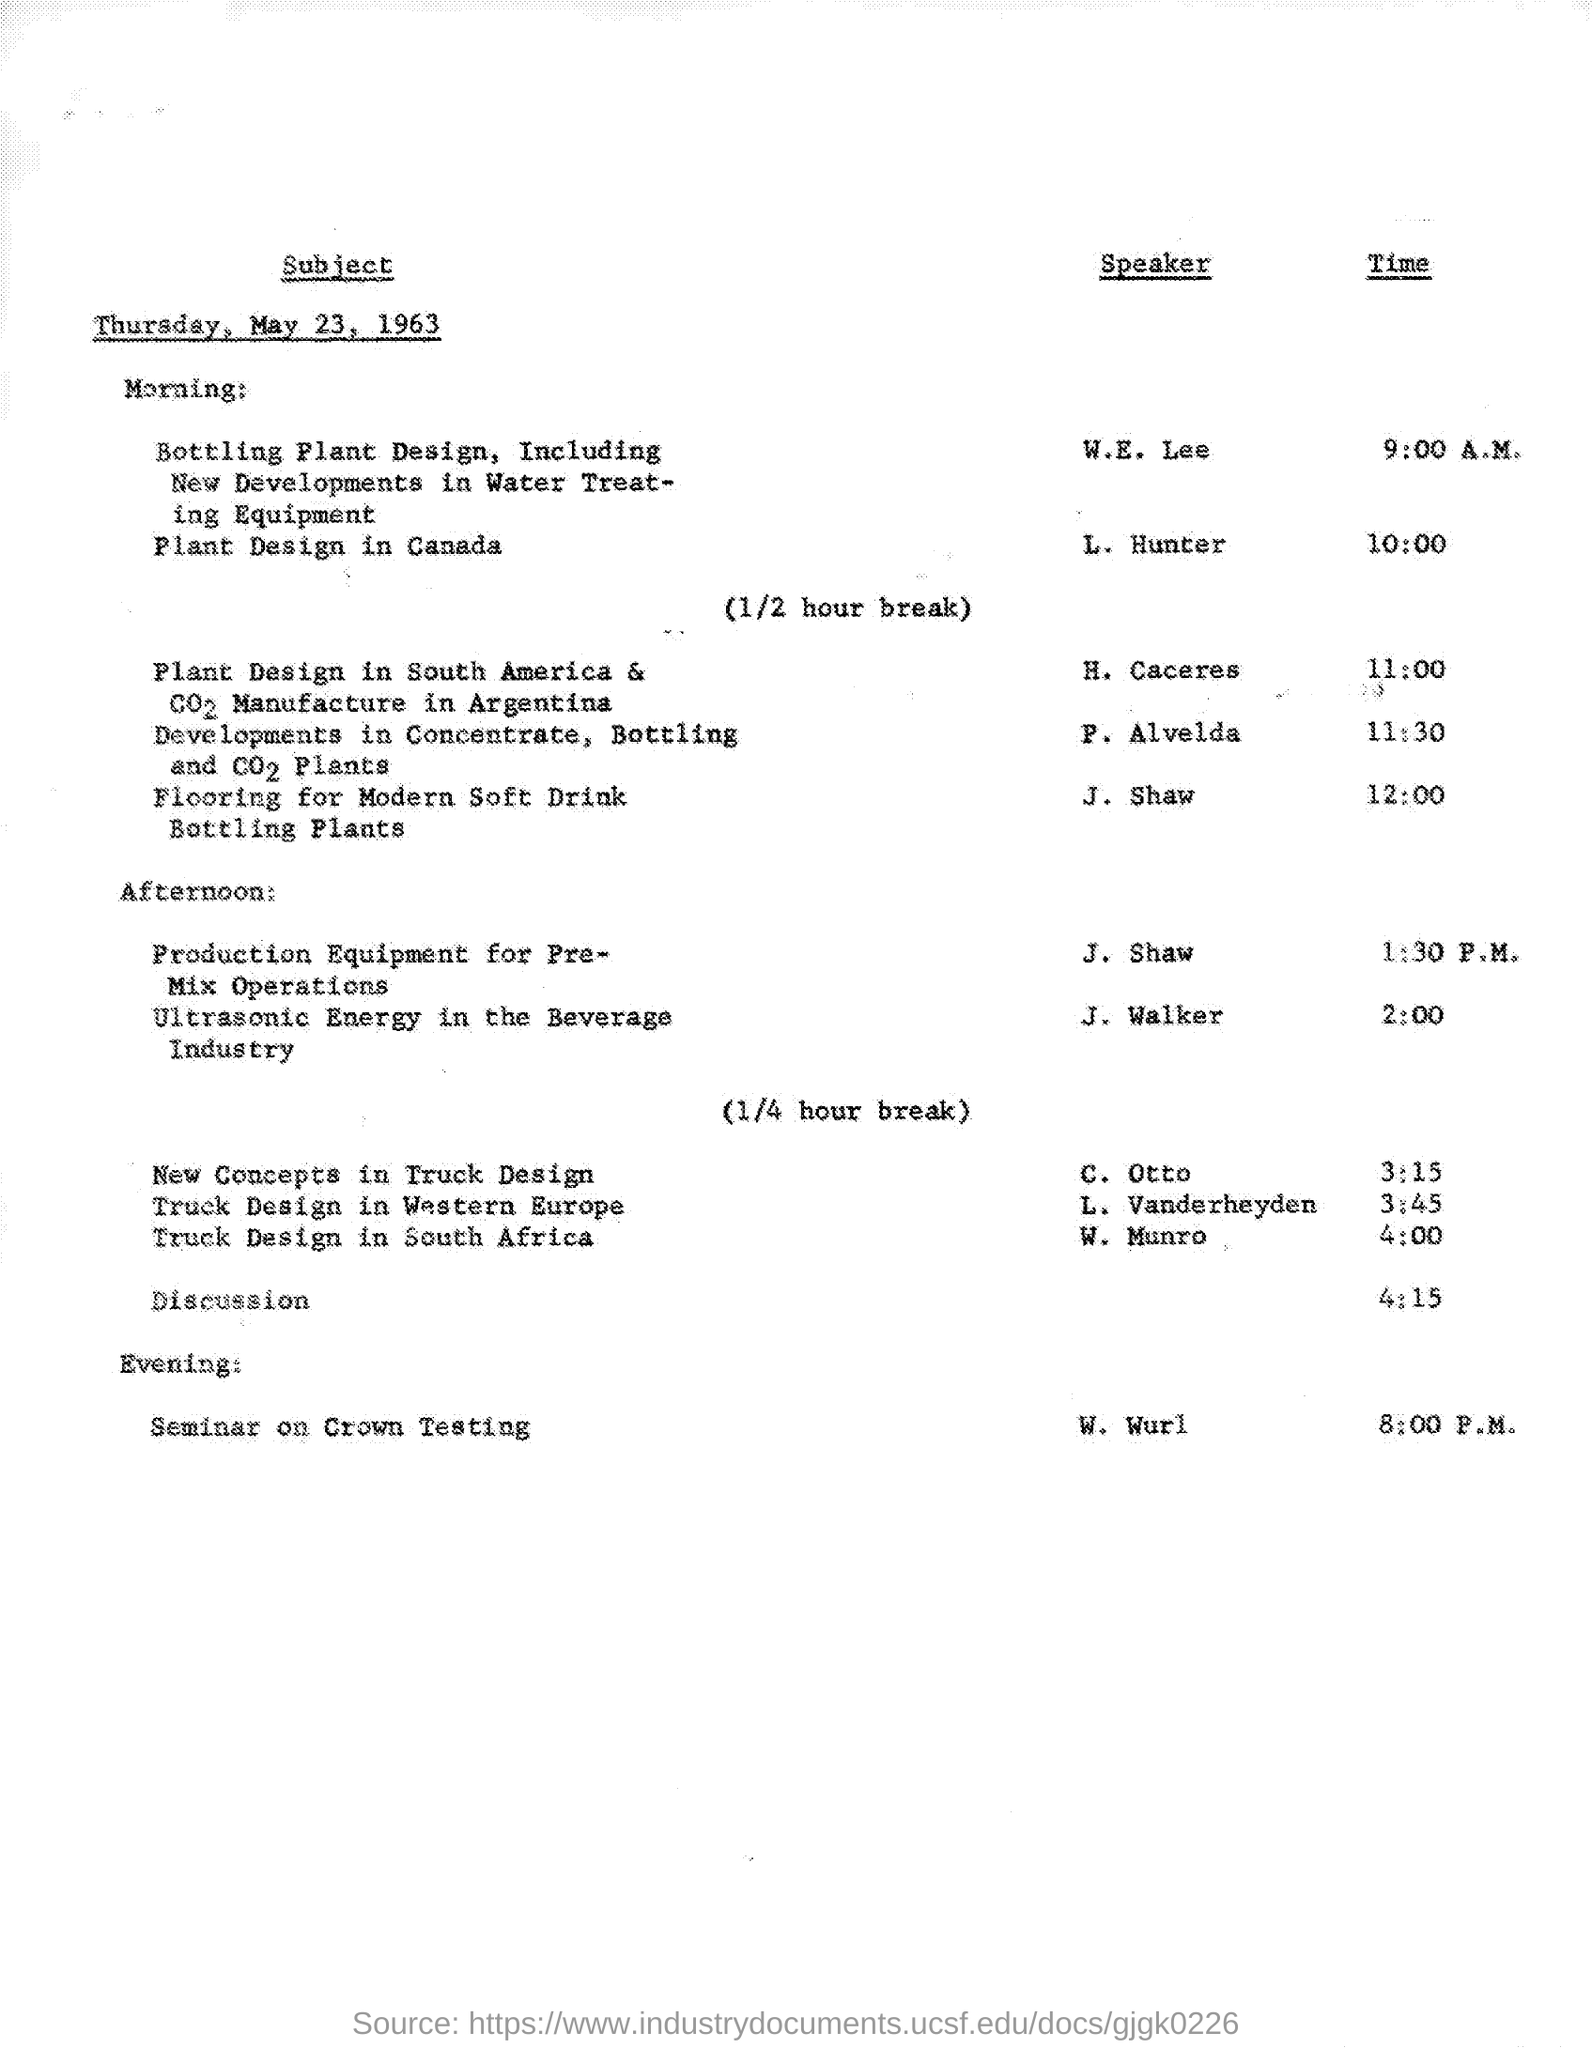Time of seminar on crown testing?
Keep it short and to the point. 8:00 p.m. Who speaks " Plant design in Canada"
Offer a terse response. L. hunter. 